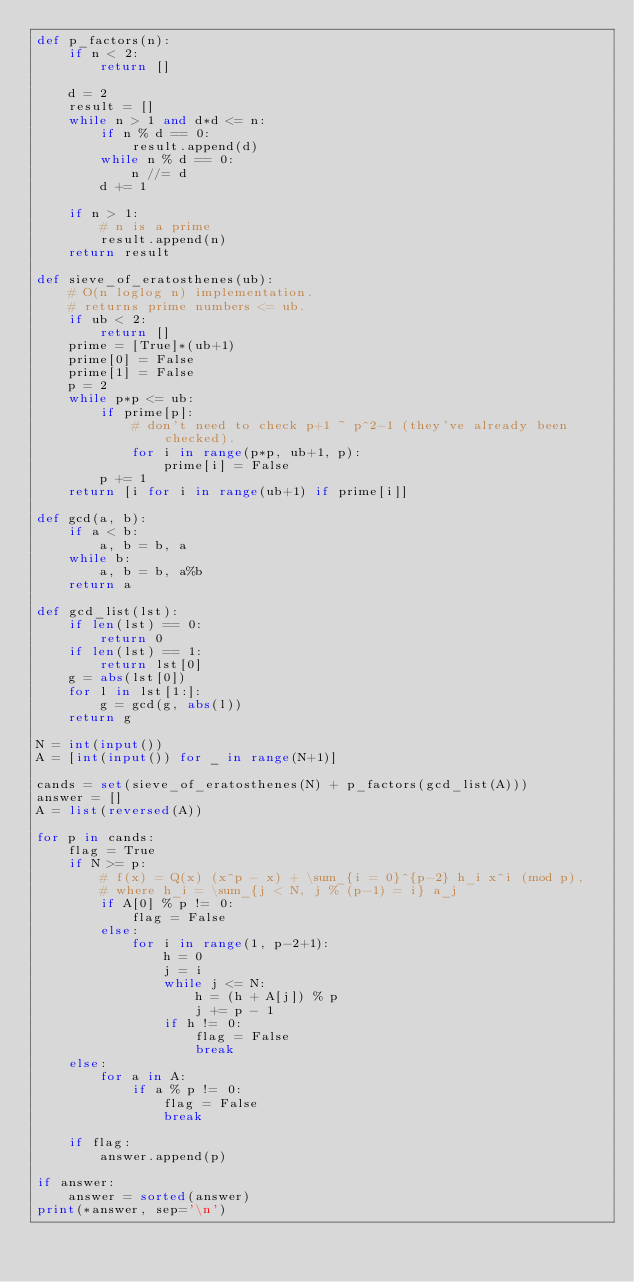Convert code to text. <code><loc_0><loc_0><loc_500><loc_500><_Python_>def p_factors(n):
    if n < 2:
        return []
    
    d = 2
    result = []
    while n > 1 and d*d <= n:
        if n % d == 0:
            result.append(d)
        while n % d == 0:
            n //= d
        d += 1
        
    if n > 1:
        # n is a prime
        result.append(n)
    return result

def sieve_of_eratosthenes(ub):
    # O(n loglog n) implementation.
    # returns prime numbers <= ub.
    if ub < 2:
        return []
    prime = [True]*(ub+1)
    prime[0] = False
    prime[1] = False
    p = 2
    while p*p <= ub:
        if prime[p]:
            # don't need to check p+1 ~ p^2-1 (they've already been checked).
            for i in range(p*p, ub+1, p):
                prime[i] = False
        p += 1
    return [i for i in range(ub+1) if prime[i]]

def gcd(a, b):
    if a < b:
        a, b = b, a
    while b:
        a, b = b, a%b
    return a

def gcd_list(lst):
    if len(lst) == 0:
        return 0
    if len(lst) == 1:
        return lst[0]
    g = abs(lst[0])
    for l in lst[1:]:
        g = gcd(g, abs(l))
    return g

N = int(input())
A = [int(input()) for _ in range(N+1)]

cands = set(sieve_of_eratosthenes(N) + p_factors(gcd_list(A)))
answer = []
A = list(reversed(A))

for p in cands:
    flag = True
    if N >= p:
        # f(x) = Q(x) (x^p - x) + \sum_{i = 0}^{p-2} h_i x^i (mod p), 
        # where h_i = \sum_{j < N, j % (p-1) = i} a_j
        if A[0] % p != 0:
            flag = False
        else:
            for i in range(1, p-2+1):
                h = 0  
                j = i
                while j <= N:
                    h = (h + A[j]) % p
                    j += p - 1
                if h != 0:
                    flag = False
                    break
    else:
        for a in A:
            if a % p != 0:
                flag = False
                break

    if flag:
        answer.append(p)

if answer:
    answer = sorted(answer)
print(*answer, sep='\n')</code> 